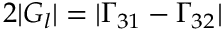Convert formula to latex. <formula><loc_0><loc_0><loc_500><loc_500>2 | G _ { l } | = | \Gamma _ { 3 1 } - \Gamma _ { 3 2 } |</formula> 